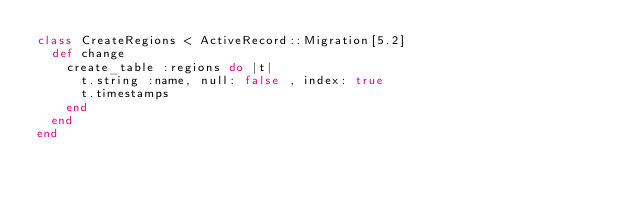<code> <loc_0><loc_0><loc_500><loc_500><_Ruby_>class CreateRegions < ActiveRecord::Migration[5.2]
  def change
    create_table :regions do |t|
      t.string :name, null: false , index: true 
      t.timestamps
    end
  end
end
</code> 